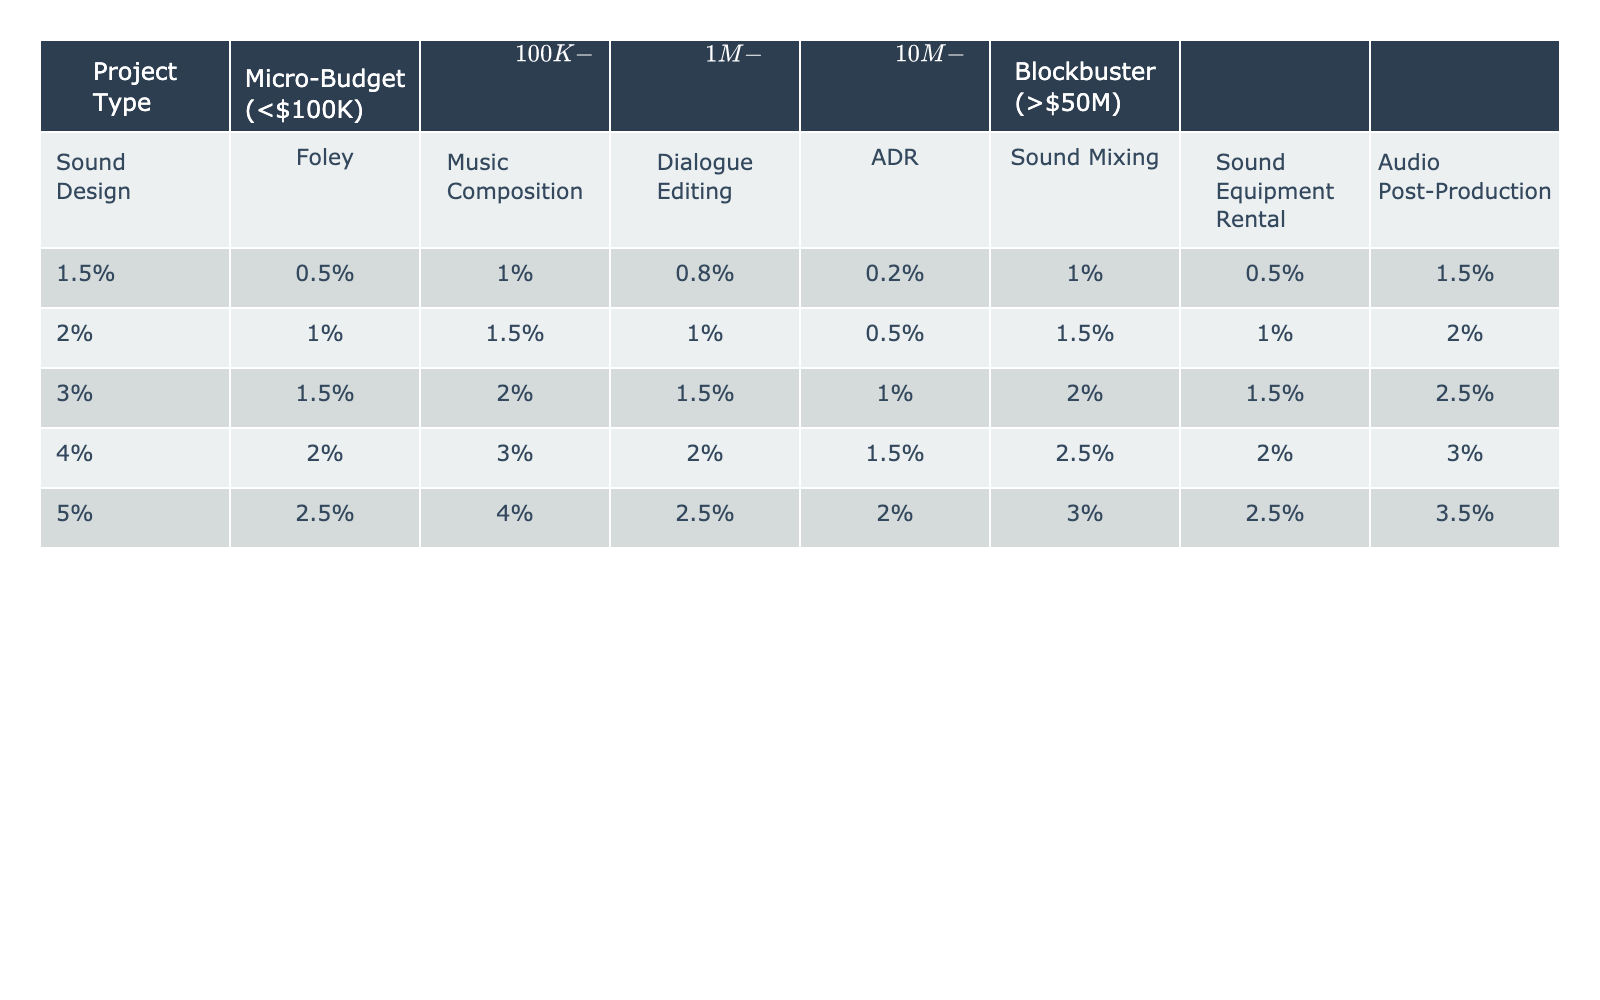What percentage of the budget is allocated for Sound Design in Blockbuster projects? For Blockbuster projects (over $50 million), the table shows that the allocation for Sound Design is 5%.
Answer: 5% In mid-budget projects, how much more is allocated to Music Composition compared to Foley? In mid-budget projects, Music Composition is allocated 2%, while Foley is allocated 1.5%. The difference is 2% - 1.5% = 0.5%.
Answer: 0.5% Is the percentage allocated to Dialogue Editing higher than that for ADR in low-budget projects? In low-budget projects, Dialogue Editing is allocated 1%, whereas ADR is allocated 0.5%. 1% is greater than 0.5%, so the statement is true.
Answer: Yes What is the average percentage allocated for Sound Equipment Rental across all budget types? To find the average, sum the percentages for all budget types: 0.5% + 1% + 1.5% + 2% + 2.5% = 7.5%. There are 5 budget types, so the average is 7.5% / 5 = 1.5%.
Answer: 1.5% Which sound-related category has the highest allocation in high-budget projects? Looking at the table for high-budget projects, the allocations are: Sound Design (4%), Foley (2%), Music Composition (3%), Dialogue Editing (2%), ADR (1.5%), Sound Mixing (2.5%), Sound Equipment Rental (2%), and Audio Post-Production (3.5%). The highest percentage is 4% for Sound Design.
Answer: Sound Design If the budget for a micro-budget project is increased to low-budget, what is the percentage increase for Audio Post-Production? In micro-budget projects, Audio Post-Production is allocated 1.5%, while in low-budget projects, it is 2%. The increase is 2% - 1.5% = 0.5%. To find the percentage increase, calculate (0.5% / 1.5%) * 100, which equals approximately 33.33%.
Answer: 33.33% How much is allocated to Music Composition in high-budget projects compared to Dialogue Editing in mid-budget projects? In high-budget projects, Music Composition is allocated 3%, while in mid-budget projects, Dialogue Editing is allocated 1.5%. The difference is 3% - 1.5% = 1.5%.
Answer: 1.5% Are the allocations for ADR in low-budget projects and Sound Mixing in micro-budget projects the same? In low-budget projects, ADR is allocated 0.5%, while in micro-budget projects, Sound Mixing is allocated 1%. Since 0.5% is not equal to 1%, the allocations are not the same.
Answer: No What is the total percentage allocated for all sound categories in mid-budget projects? The allocation for mid-budget projects for each sound category is: Sound Design (3%), Foley (1.5%), Music Composition (2%), Dialogue Editing (1.5%), ADR (1%), Sound Mixing (2%), Sound Equipment Rental (1.5%), and Audio Post-Production (2.5%). Summing these gives 3% + 1.5% + 2% + 1.5% + 1% + 2% + 1.5% + 2.5% = 15%.
Answer: 15% 